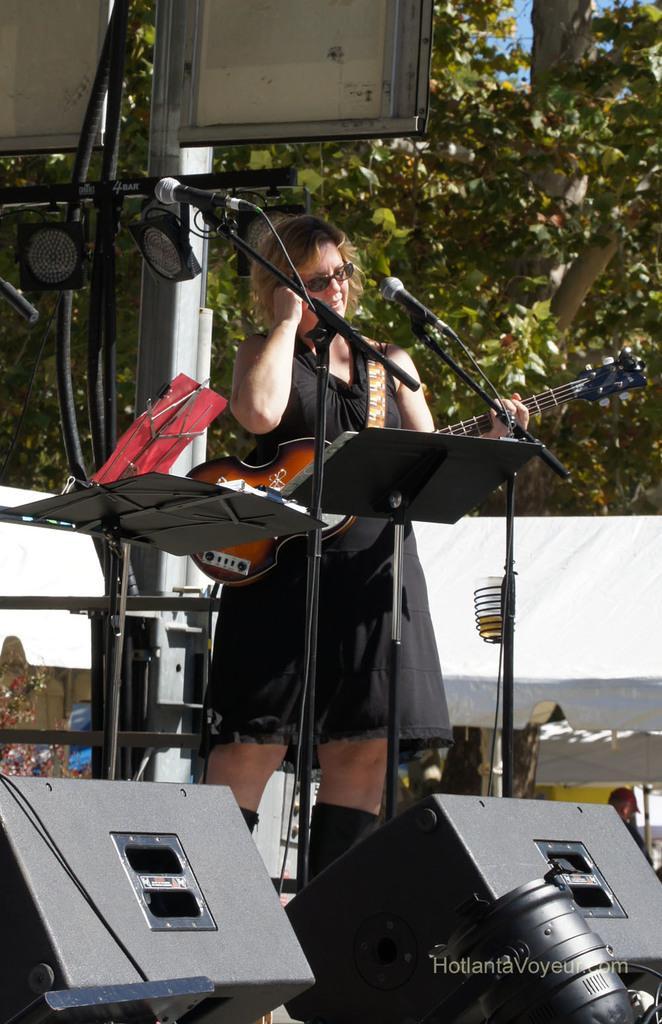Could you give a brief overview of what you see in this image? In the foreground I can see a woman is playing a guitar is standing in front of mike's. At the bottom I can see speakers and text. In the background I can see trees, shed, wall, some objects and the sky. This image is taken, may be during a day. 